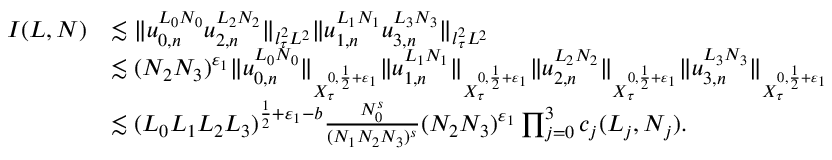Convert formula to latex. <formula><loc_0><loc_0><loc_500><loc_500>\begin{array} { r l } { I ( L , N ) } & { \lesssim \| u _ { 0 , n } ^ { L _ { 0 } N _ { 0 } } u _ { 2 , n } ^ { L _ { 2 } N _ { 2 } } \| _ { l _ { \tau } ^ { 2 } L ^ { 2 } } \| u _ { 1 , n } ^ { L _ { 1 } N _ { 1 } } u _ { 3 , n } ^ { L _ { 3 } N _ { 3 } } \| _ { l _ { \tau } ^ { 2 } L ^ { 2 } } } \\ & { \lesssim ( N _ { 2 } N _ { 3 } ) ^ { \varepsilon _ { 1 } } \| u _ { 0 , n } ^ { L _ { 0 } N _ { 0 } } \| _ { X _ { \tau } ^ { 0 , \frac { 1 } { 2 } + \varepsilon _ { 1 } } } \| u _ { 1 , n } ^ { L _ { 1 } N _ { 1 } } \| _ { X _ { \tau } ^ { 0 , \frac { 1 } { 2 } + \varepsilon _ { 1 } } } \| u _ { 2 , n } ^ { L _ { 2 } N _ { 2 } } \| _ { X _ { \tau } ^ { 0 , \frac { 1 } { 2 } + \varepsilon _ { 1 } } } \| u _ { 3 , n } ^ { L _ { 3 } N _ { 3 } } \| _ { X _ { \tau } ^ { 0 , \frac { 1 } { 2 } + \varepsilon _ { 1 } } } } \\ & { \lesssim ( L _ { 0 } L _ { 1 } L _ { 2 } L _ { 3 } ) ^ { \frac { 1 } { 2 } + \varepsilon _ { 1 } - b } \frac { N _ { 0 } ^ { s } } { ( N _ { 1 } N _ { 2 } N _ { 3 } ) ^ { s } } ( N _ { 2 } N _ { 3 } ) ^ { \varepsilon _ { 1 } } \prod _ { j = 0 } ^ { 3 } c _ { j } ( L _ { j } , N _ { j } ) . } \end{array}</formula> 